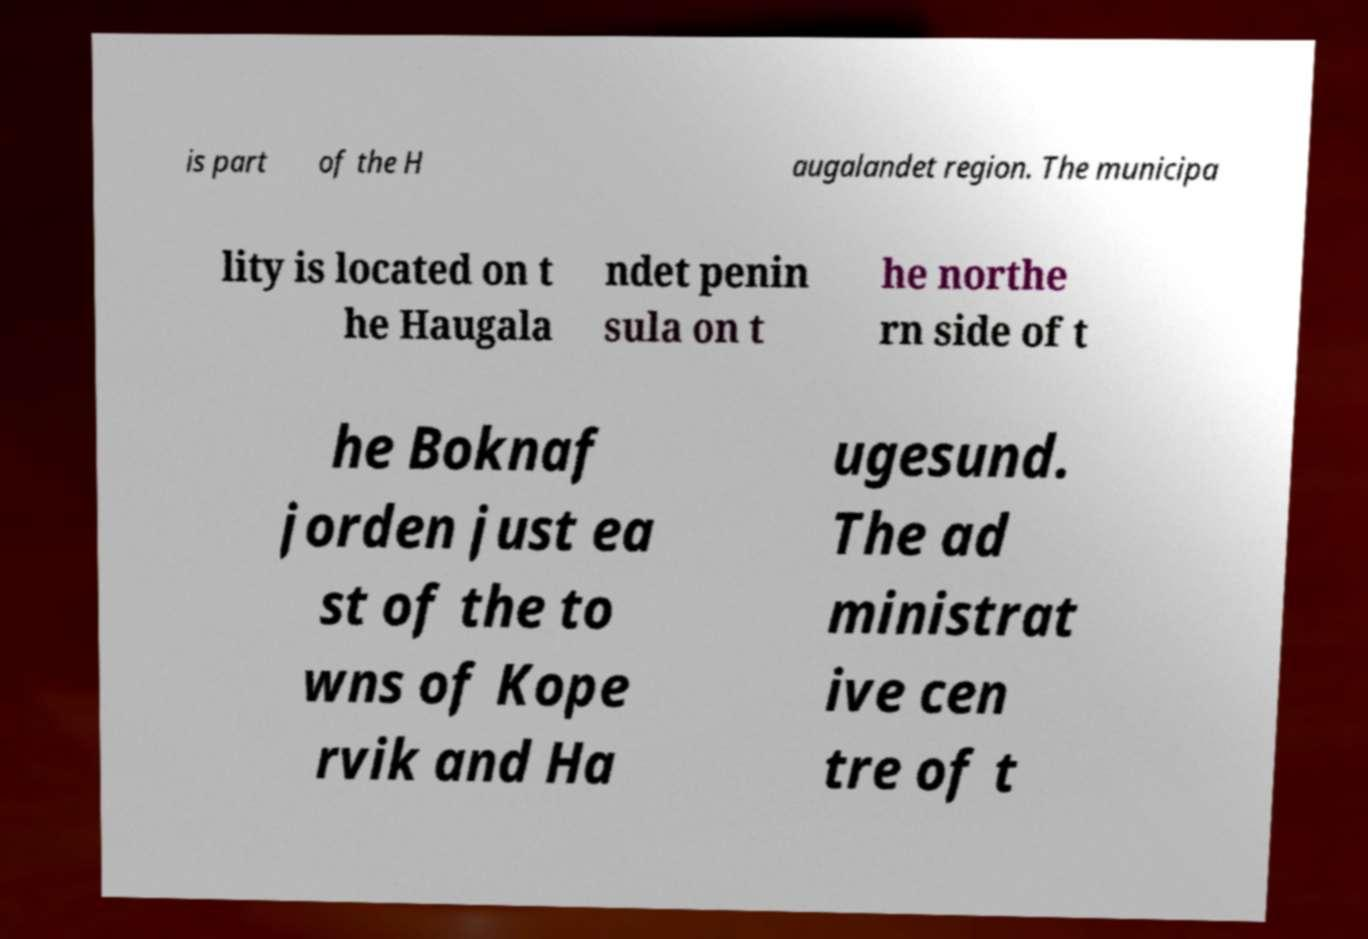There's text embedded in this image that I need extracted. Can you transcribe it verbatim? is part of the H augalandet region. The municipa lity is located on t he Haugala ndet penin sula on t he northe rn side of t he Boknaf jorden just ea st of the to wns of Kope rvik and Ha ugesund. The ad ministrat ive cen tre of t 